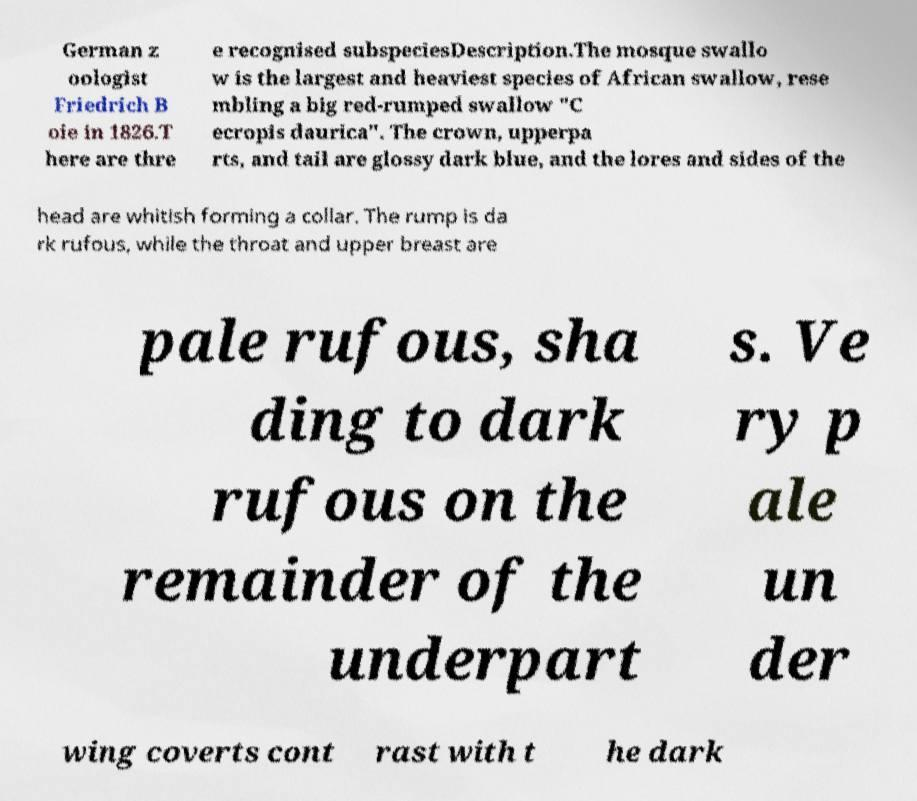Can you read and provide the text displayed in the image?This photo seems to have some interesting text. Can you extract and type it out for me? German z oologist Friedrich B oie in 1826.T here are thre e recognised subspeciesDescription.The mosque swallo w is the largest and heaviest species of African swallow, rese mbling a big red-rumped swallow "C ecropis daurica". The crown, upperpa rts, and tail are glossy dark blue, and the lores and sides of the head are whitish forming a collar. The rump is da rk rufous, while the throat and upper breast are pale rufous, sha ding to dark rufous on the remainder of the underpart s. Ve ry p ale un der wing coverts cont rast with t he dark 